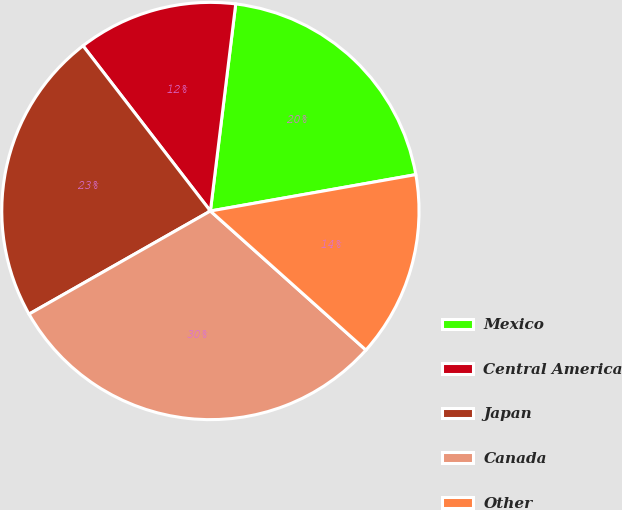Convert chart. <chart><loc_0><loc_0><loc_500><loc_500><pie_chart><fcel>Mexico<fcel>Central America<fcel>Japan<fcel>Canada<fcel>Other<nl><fcel>20.27%<fcel>12.39%<fcel>22.77%<fcel>30.16%<fcel>14.4%<nl></chart> 